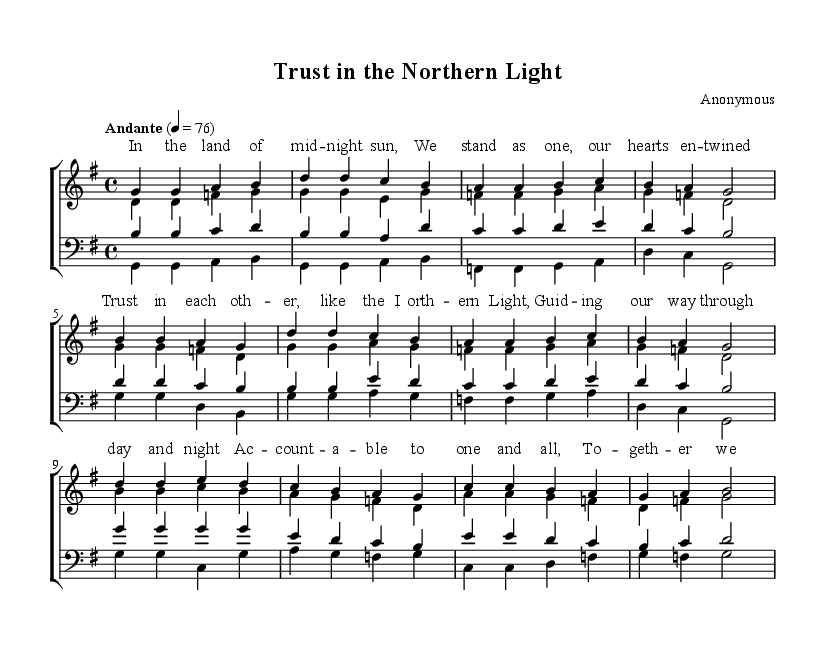What is the key signature of this music? The key signature is G major, which has one sharp (F#). This can be identified by looking at the key signature indicated at the beginning of the staff.
Answer: G major What is the time signature of the piece? The time signature is 4/4, which means there are four beats in each measure and a quarter note receives one beat. This is noted at the beginning of the staff right after the key signature.
Answer: 4/4 What is the tempo marking for this piece? The tempo marking is "Andante" at quarter note equals 76. This indicates a moderately slow tempo. It is specified in the tempo indication found at the beginning of the score.
Answer: Andante How many verses are there in the score? There are three verses in the score, identified as the soprano and chorus sections. Each part has a corresponding verse labeled in the provided structure.
Answer: Three What do the lyrics of the bridge section emphasize? The lyrics of the bridge section emphasize accountability and unity among the community as indicated by the text detailing rising together and standing tall. This can be inferred by analyzing the words specifically assigned to the bridge section, highlighting themes of collective responsibility.
Answer: Accountability What vocal parts are included in this piece? The piece includes soprano, alto, tenor, and bass vocal parts, as indicated by the labels for each staff section in the score. This showcases the four-part choral arrangement common in choral music.
Answer: Soprano, alto, tenor, bass How does the chorus reflect community trust? The chorus reflects community trust through lyrics that emphasize trusting one another and comparison to the Northern Light, symbolizing guidance. The lyrics' themes and sentiments are crafted to express a deep connection and reliance among the singers.
Answer: Trust 